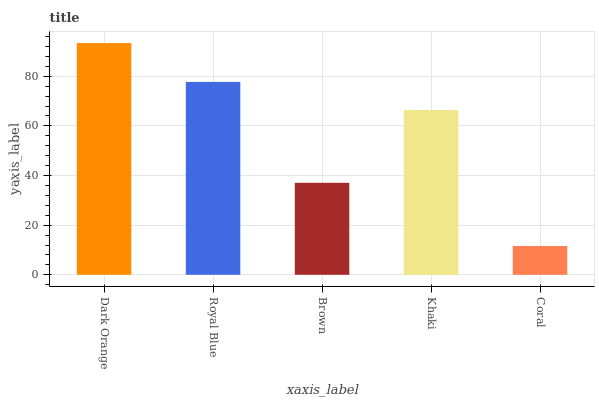Is Coral the minimum?
Answer yes or no. Yes. Is Dark Orange the maximum?
Answer yes or no. Yes. Is Royal Blue the minimum?
Answer yes or no. No. Is Royal Blue the maximum?
Answer yes or no. No. Is Dark Orange greater than Royal Blue?
Answer yes or no. Yes. Is Royal Blue less than Dark Orange?
Answer yes or no. Yes. Is Royal Blue greater than Dark Orange?
Answer yes or no. No. Is Dark Orange less than Royal Blue?
Answer yes or no. No. Is Khaki the high median?
Answer yes or no. Yes. Is Khaki the low median?
Answer yes or no. Yes. Is Dark Orange the high median?
Answer yes or no. No. Is Brown the low median?
Answer yes or no. No. 